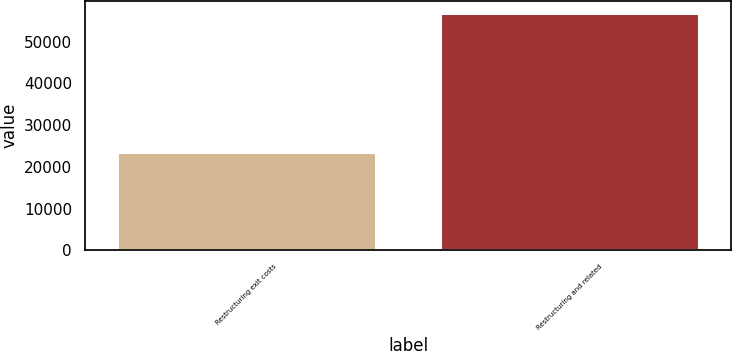Convert chart. <chart><loc_0><loc_0><loc_500><loc_500><bar_chart><fcel>Restructuring exit costs<fcel>Restructuring and related<nl><fcel>23432<fcel>56946<nl></chart> 